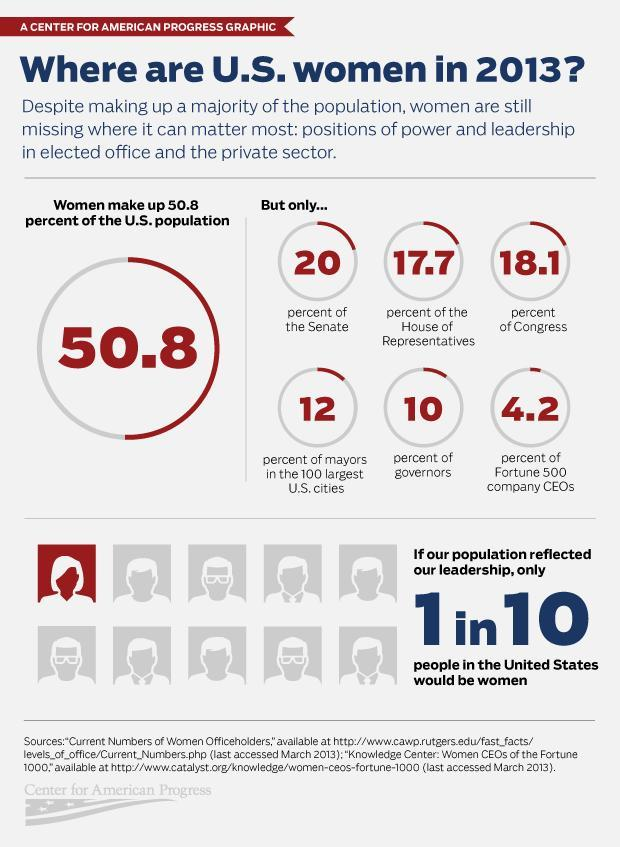What percentage of governors are women in 2013?
Answer the question with a short phrase. 10 What percentage of Senators are women in 2013? 20% 